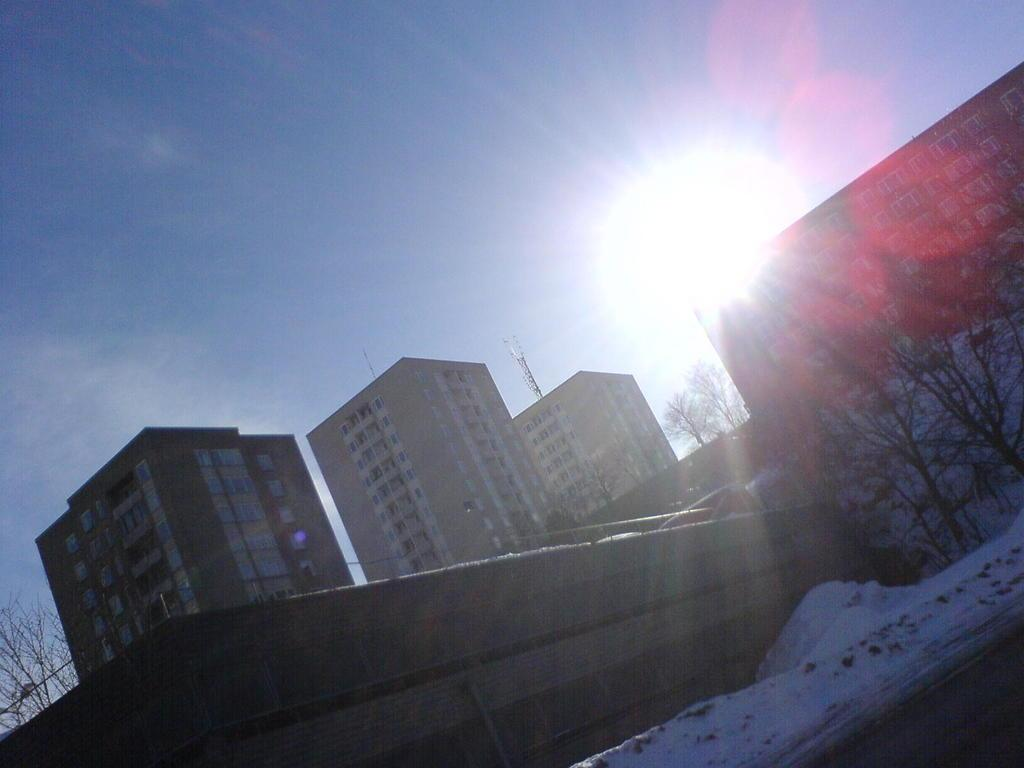What type of vegetation can be seen in the image? There are trees in the image. What structure is visible in the image? There is a wall in the image. What weather condition is depicted in the image? There is snow in the image. What type of man-made structures are present in the image? There are buildings in the image. What is visible in the background of the image? The sky is visible in the background of the image. Can you see any waves in the image? There are no waves present in the image. What type of art is displayed on the wall in the image? There is no art displayed on the wall in the image; it is a plain wall. 